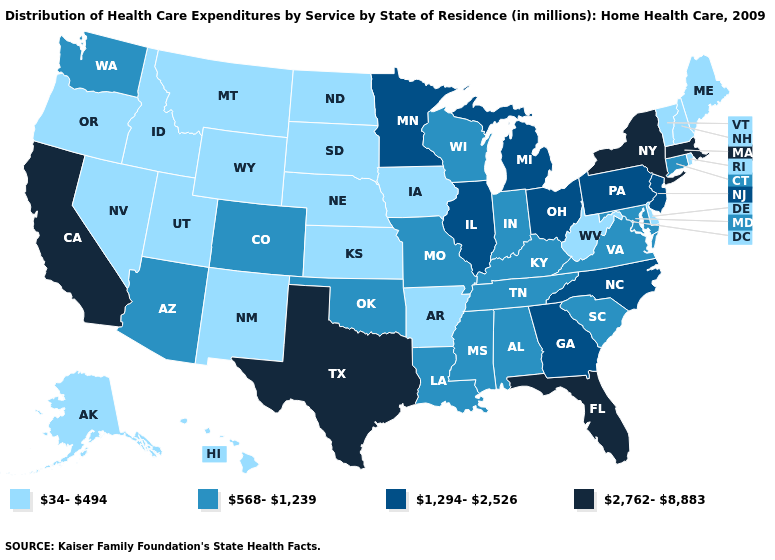Is the legend a continuous bar?
Answer briefly. No. Among the states that border Indiana , which have the lowest value?
Short answer required. Kentucky. Among the states that border Louisiana , which have the highest value?
Give a very brief answer. Texas. What is the value of Missouri?
Quick response, please. 568-1,239. What is the value of Vermont?
Keep it brief. 34-494. Among the states that border Delaware , does Maryland have the lowest value?
Keep it brief. Yes. What is the value of Ohio?
Short answer required. 1,294-2,526. Does North Dakota have the highest value in the MidWest?
Answer briefly. No. Name the states that have a value in the range 2,762-8,883?
Concise answer only. California, Florida, Massachusetts, New York, Texas. Name the states that have a value in the range 2,762-8,883?
Keep it brief. California, Florida, Massachusetts, New York, Texas. What is the lowest value in states that border Massachusetts?
Answer briefly. 34-494. What is the value of Utah?
Answer briefly. 34-494. Which states have the lowest value in the USA?
Keep it brief. Alaska, Arkansas, Delaware, Hawaii, Idaho, Iowa, Kansas, Maine, Montana, Nebraska, Nevada, New Hampshire, New Mexico, North Dakota, Oregon, Rhode Island, South Dakota, Utah, Vermont, West Virginia, Wyoming. Which states have the highest value in the USA?
Quick response, please. California, Florida, Massachusetts, New York, Texas. Does Washington have the same value as Pennsylvania?
Write a very short answer. No. 